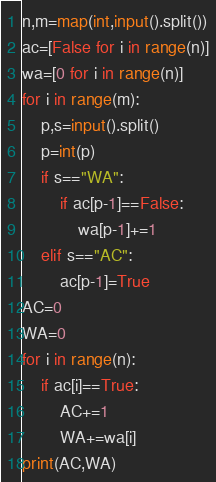Convert code to text. <code><loc_0><loc_0><loc_500><loc_500><_Python_>n,m=map(int,input().split())
ac=[False for i in range(n)]
wa=[0 for i in range(n)]
for i in range(m):
    p,s=input().split()
    p=int(p)
    if s=="WA":
        if ac[p-1]==False:
            wa[p-1]+=1
    elif s=="AC":
        ac[p-1]=True
AC=0
WA=0
for i in range(n):
    if ac[i]==True:
        AC+=1
        WA+=wa[i]
print(AC,WA)</code> 